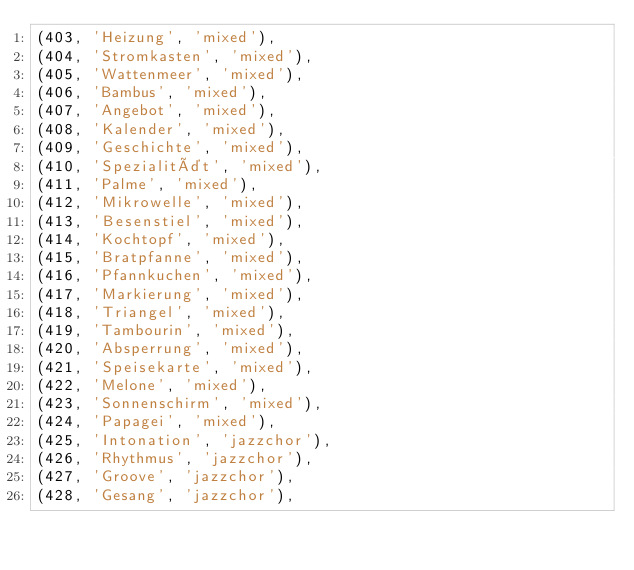Convert code to text. <code><loc_0><loc_0><loc_500><loc_500><_SQL_>(403, 'Heizung', 'mixed'),
(404, 'Stromkasten', 'mixed'),
(405, 'Wattenmeer', 'mixed'),
(406, 'Bambus', 'mixed'),
(407, 'Angebot', 'mixed'),
(408, 'Kalender', 'mixed'),
(409, 'Geschichte', 'mixed'),
(410, 'Spezialität', 'mixed'),
(411, 'Palme', 'mixed'),
(412, 'Mikrowelle', 'mixed'),
(413, 'Besenstiel', 'mixed'),
(414, 'Kochtopf', 'mixed'),
(415, 'Bratpfanne', 'mixed'),
(416, 'Pfannkuchen', 'mixed'),
(417, 'Markierung', 'mixed'),
(418, 'Triangel', 'mixed'),
(419, 'Tambourin', 'mixed'),
(420, 'Absperrung', 'mixed'),
(421, 'Speisekarte', 'mixed'),
(422, 'Melone', 'mixed'),
(423, 'Sonnenschirm', 'mixed'),
(424, 'Papagei', 'mixed'),
(425, 'Intonation', 'jazzchor'),
(426, 'Rhythmus', 'jazzchor'),
(427, 'Groove', 'jazzchor'),
(428, 'Gesang', 'jazzchor'),</code> 